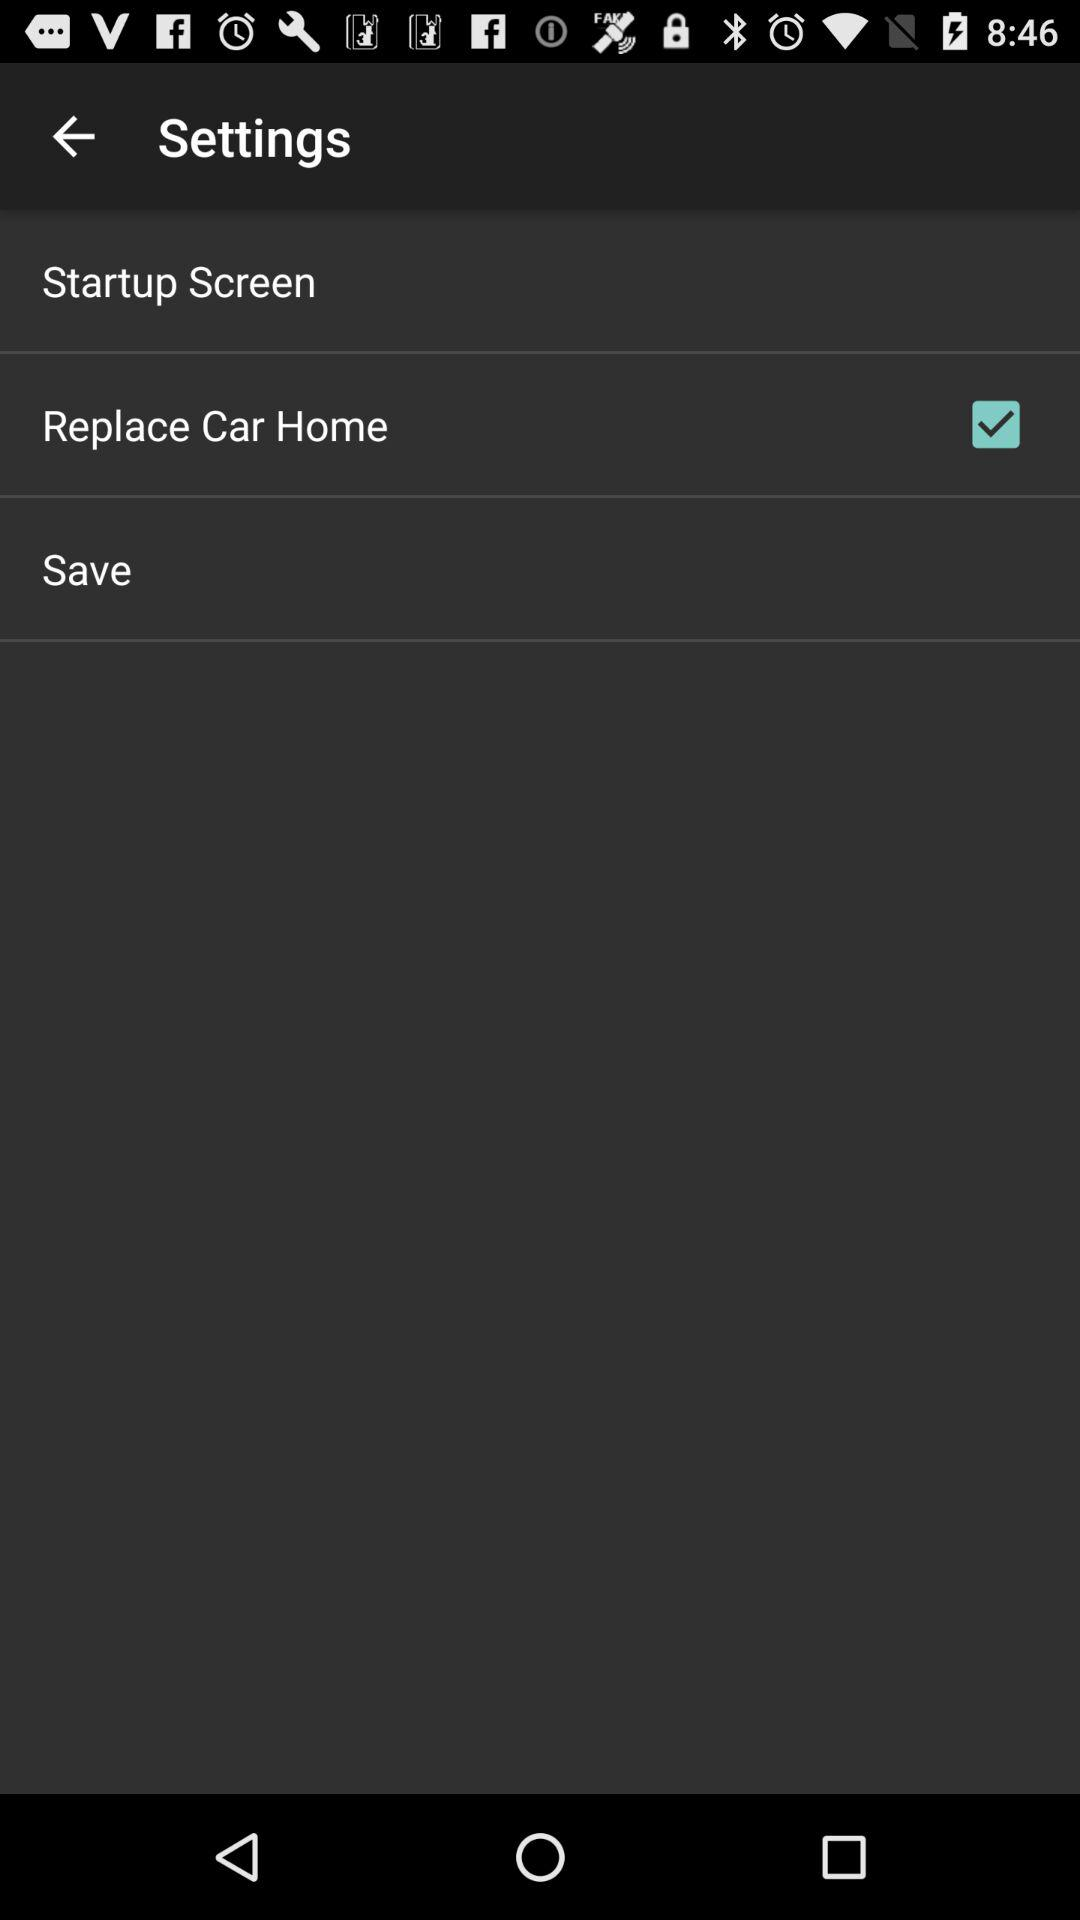What is the status of the "Replace Car Home"? The status is on. 